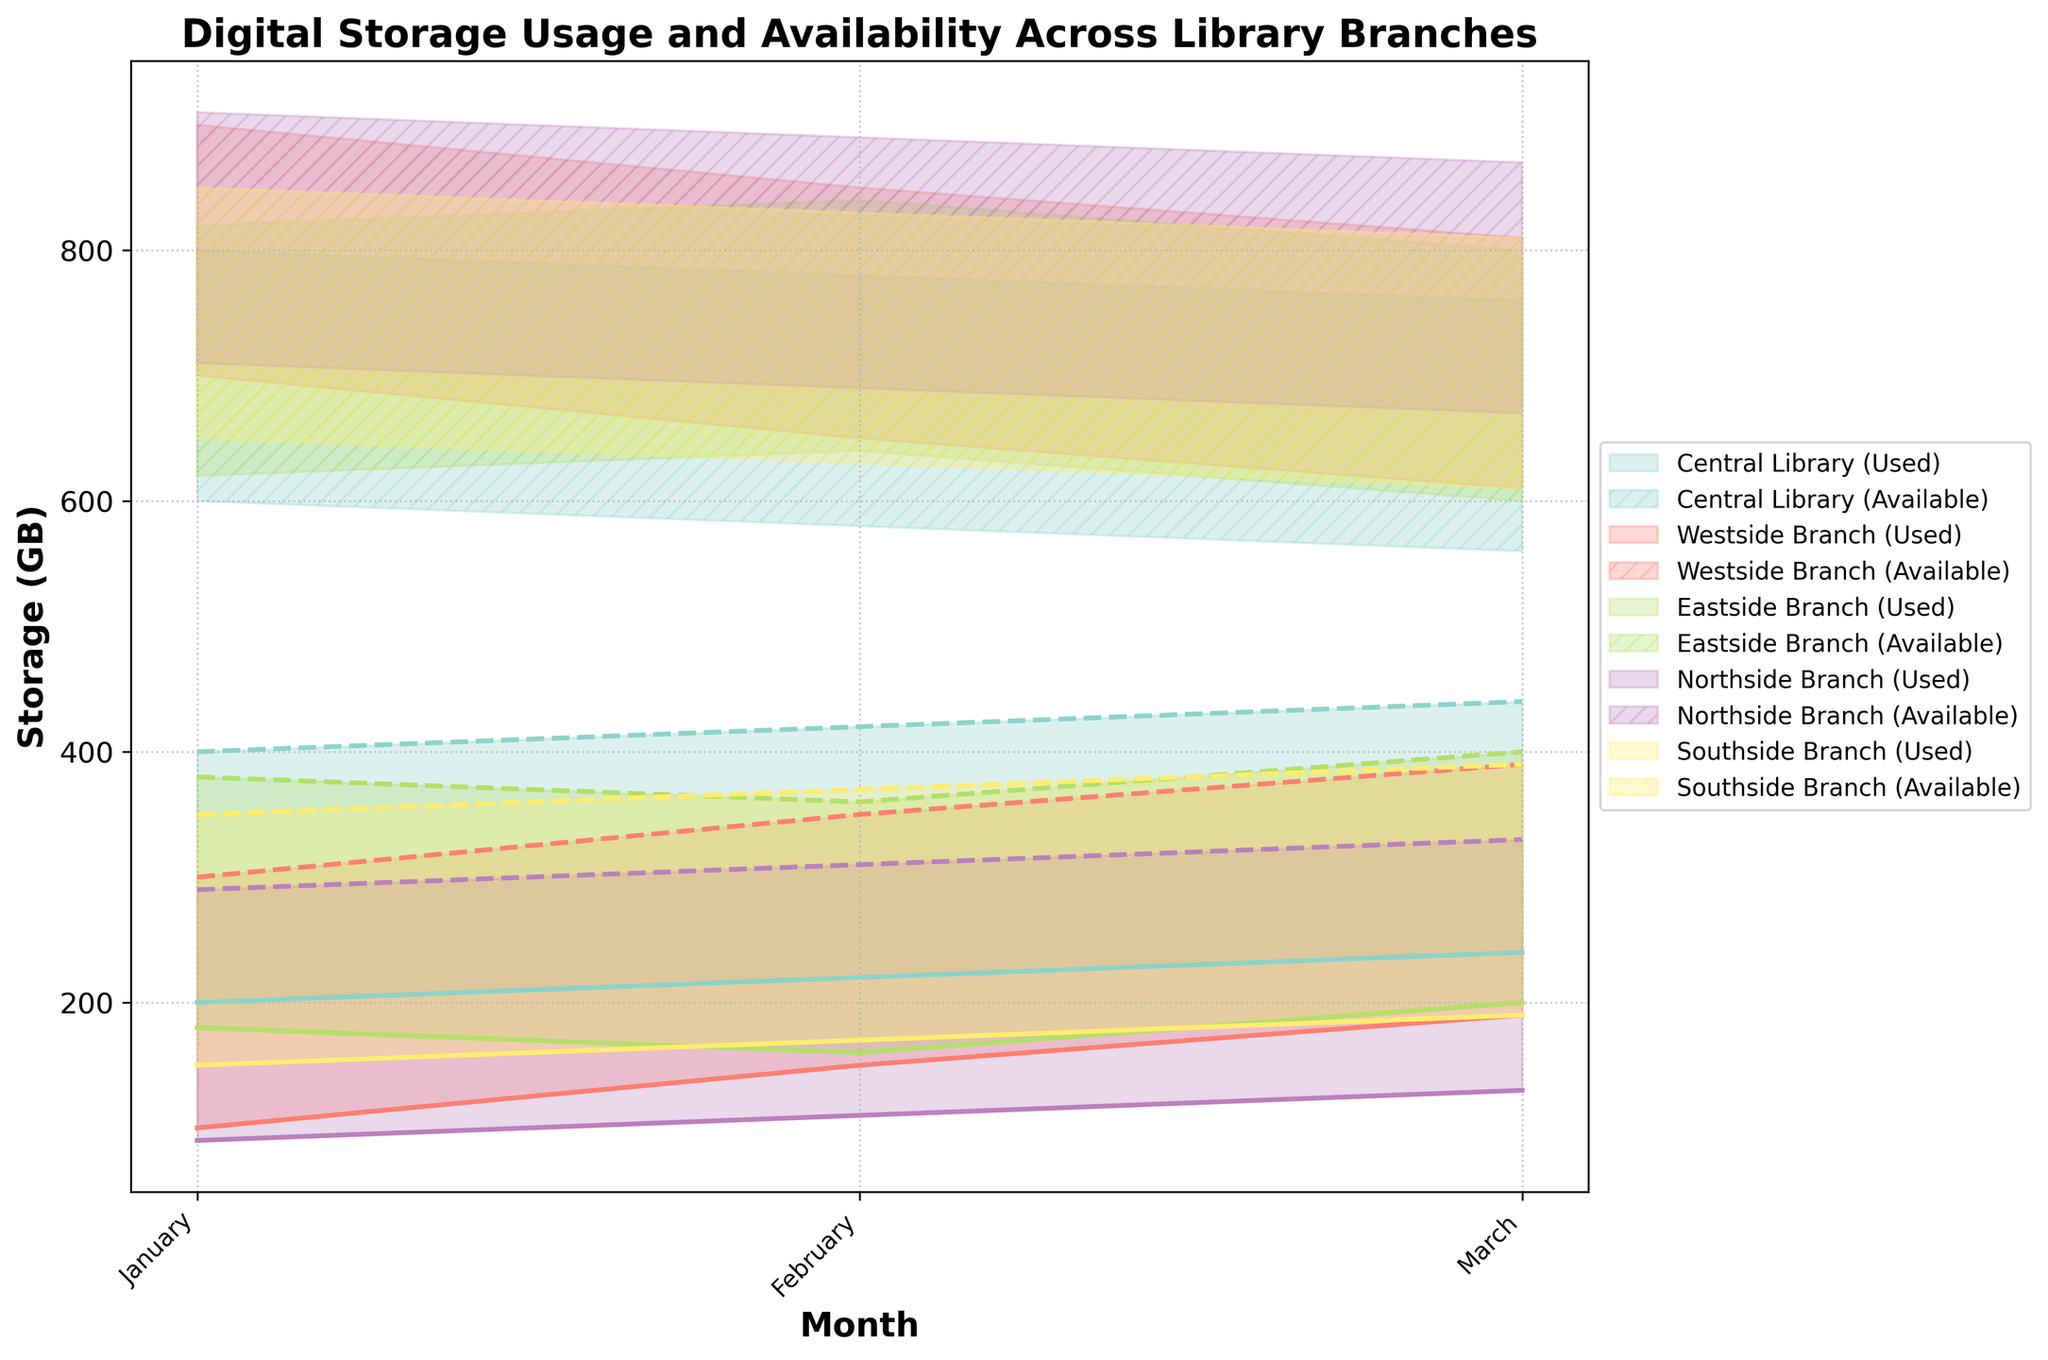What's the title of the chart? The title is usually at the top of the chart and gives an overview of what the chart represents. In this case, the title of the chart can be found at the top of the figure.
Answer: Digital Storage Usage and Availability Across Library Branches What months are represented in the chart? The months are typically displayed along the x-axis in a chronological order. In this chart, the x-axis labels show the months.
Answer: January, February, March Which branch has the highest maximum storage used in March? To determine this, look at the highest point of the storage used area (the solid lines) in March. Compare the values for each branch to identify the maximum.
Answer: Central Library Is there a branch that has a consistent increase in storage used from January to March? Observe the solid lines representing storage used for each branch. A consistent increase would be an upward slope from January to March without any dips.
Answer: Central Library How does the minimum storage available range for Westside Branch change over the months? Look at the difference between the lowest point of the availability area (the hatched areas) for Westside Branch from January to March. Check for any decreasing or increasing trends over these months.
Answer: Decreases from 700GB in January, to 650GB in February, to 610GB in March Which branch has the smallest range of maximum storage available in February? The range of maximum storage available can be found by looking at the highest points of the hatched areas for each branch in February and identifying the smallest difference between them.
Answer: Southside Branch What is the average maximum storage used for the Eastside Branch across all months? Calculate the average by adding the maximum storage used values for Eastside Branch across January, February, and March, then dividing by 3.
Answer: (380 + 360 + 400) / 3 = 380 Compare the storage usage between Northside Branch and Southside Branch in January. Compare the areas representing storage used (solid lines) for both branches in January. Identify which branch has higher and lower values.
Answer: Northside Branch: 90-290GB, Southside Branch: 150-350GB Which branch has the most fluctuating storage availability range, and how can you tell? The most fluctuating range would be identified by the greatest variation between the minimum and maximum storage available lines (hatched areas). Compare these variations across all branches.
Answer: Central Library (large fluctuation in both used and available storage) How does the storage used by the Central Library compare to its available storage in March? For the Central Library in March, compare the values of the solid line (storage used) to the corresponding hatched area (storage available). Observe if the storage used is approaching or far from the available storage.
Answer: Storage used: 240-440GB, Storage available: 560-760GB 